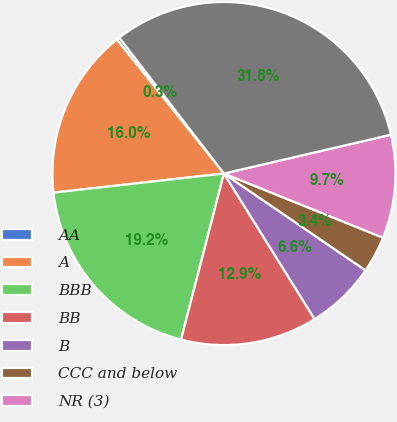Convert chart to OTSL. <chart><loc_0><loc_0><loc_500><loc_500><pie_chart><fcel>AA<fcel>A<fcel>BBB<fcel>BB<fcel>B<fcel>CCC and below<fcel>NR (3)<fcel>Total net credit default<nl><fcel>0.29%<fcel>16.05%<fcel>19.2%<fcel>12.89%<fcel>6.59%<fcel>3.44%<fcel>9.74%<fcel>31.81%<nl></chart> 